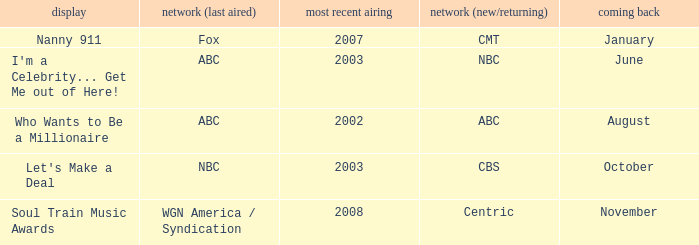When did a show last aired in 2002 return? August. 